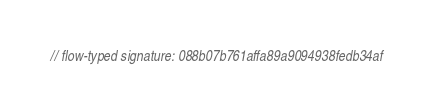Convert code to text. <code><loc_0><loc_0><loc_500><loc_500><_JavaScript_>// flow-typed signature: 088b07b761affa89a9094938fedb34af</code> 